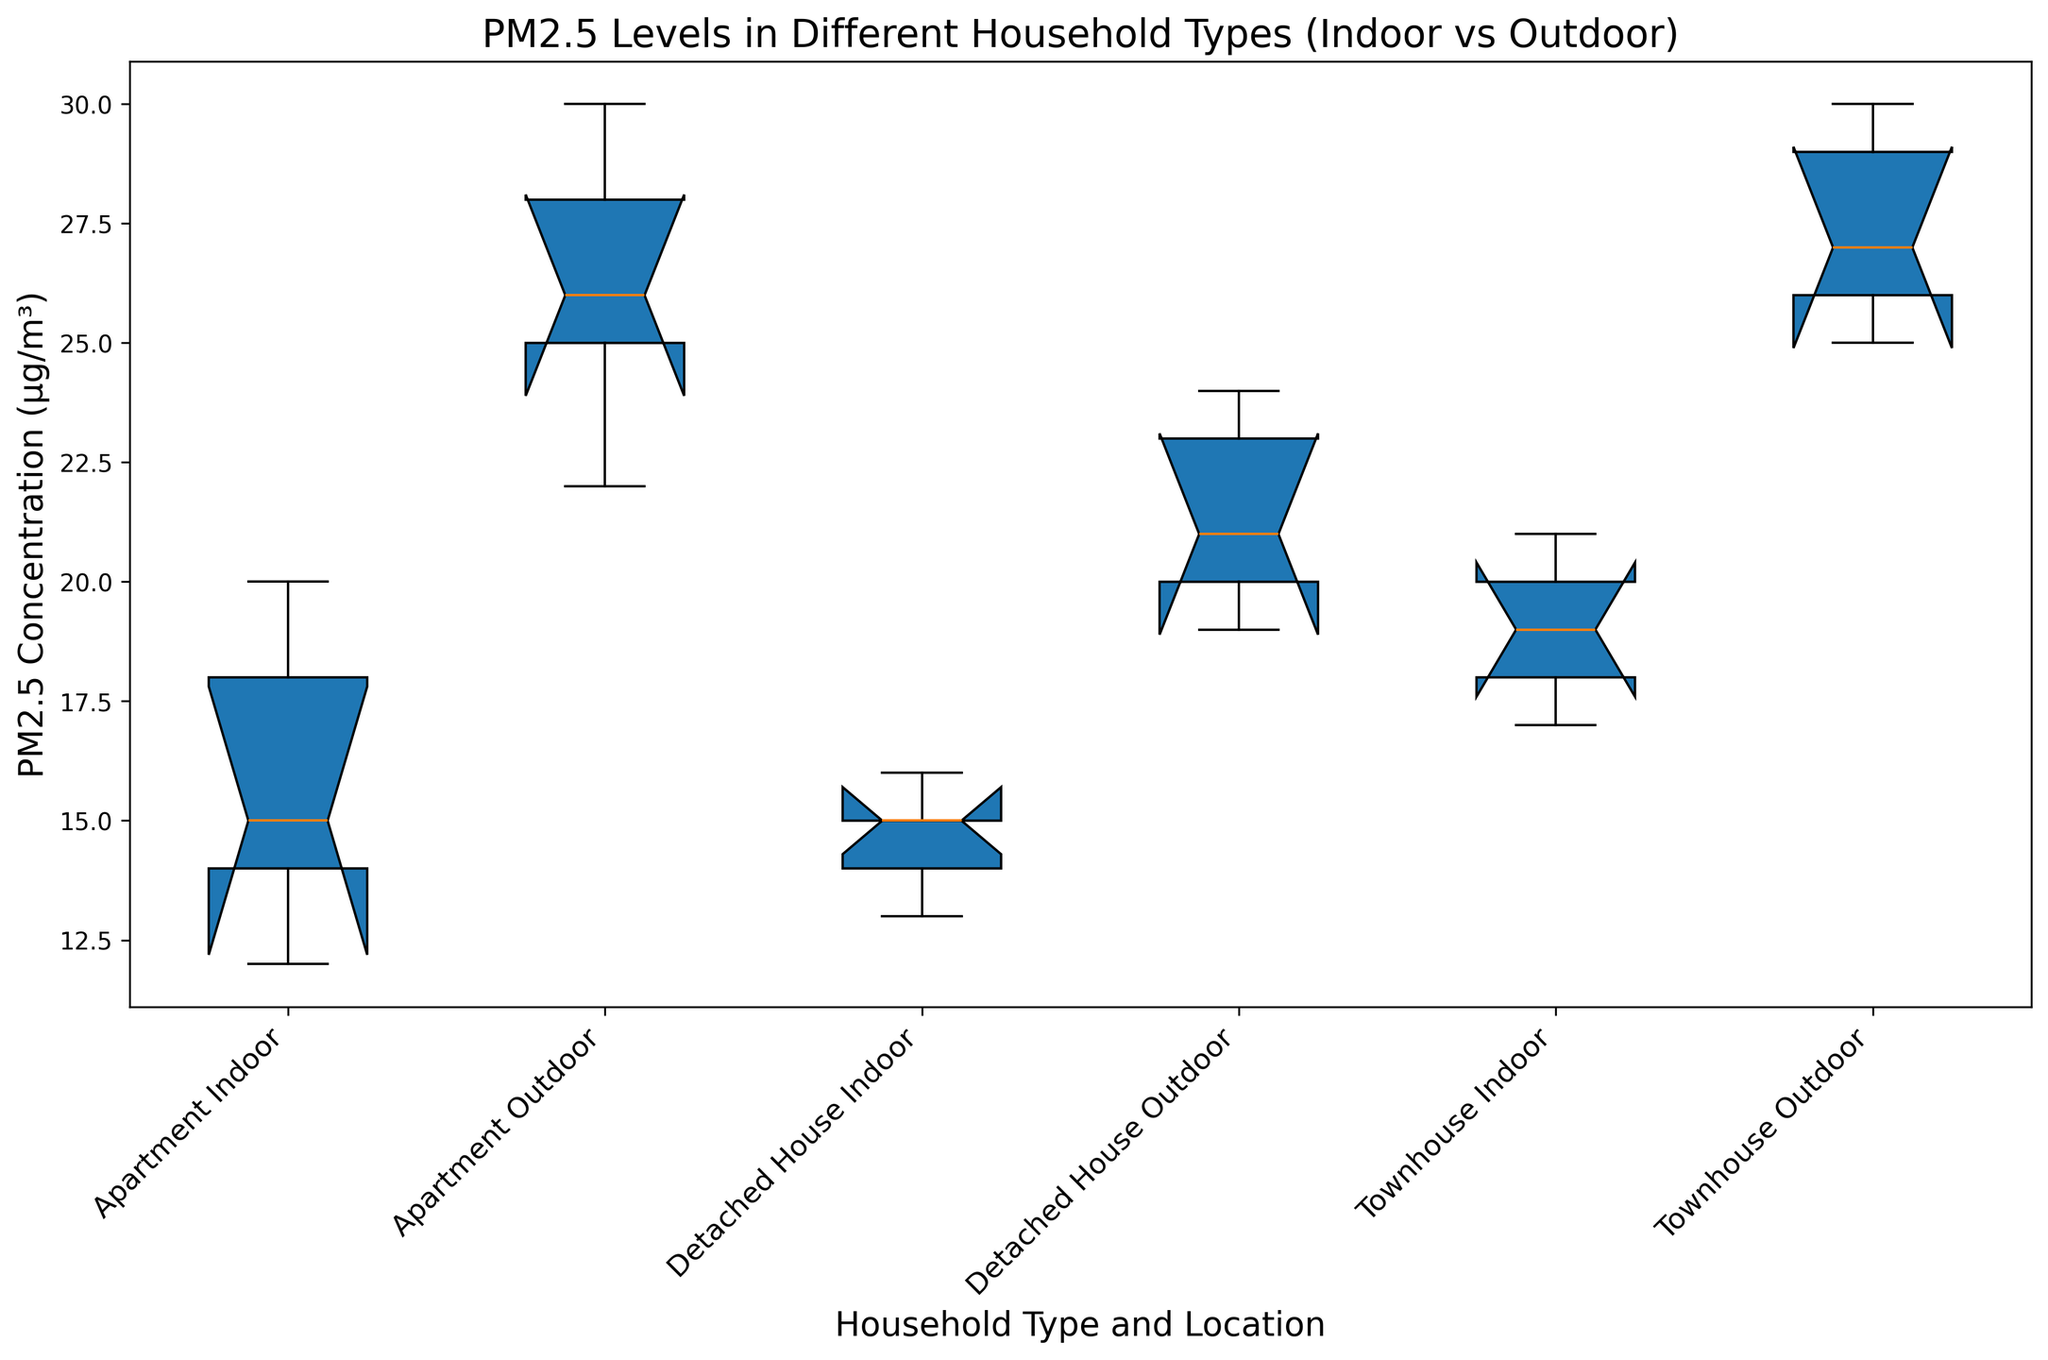What's the overall median PM2.5 concentration for Apartments (including both Indoor and Outdoor)? Calculate the median values of both groups (Indoor and Outdoor) separately, then determine the middle number of the combined list 12, 14, 15, 18, 20 (Indoor) and 22, 25, 26, 28, 30 (Outdoor). Combining and sorting these values gives 12, 14, 15, 18, 20, 22, 25, 26, 28, 30. The median value is the average of 20 and 22, which is 21.
Answer: 21 Which household type has the highest median PM2.5 concentration outdoors? Compare the median values of PM2.5 concentrations outdoors for Apartments, Detached Houses, and Townhouses. The respective median values are: 26 for Apartments, 21 for Detached Houses, and 27 for Townhouses. Therefore, Townhouses have the highest median PM2.5 concentration.
Answer: Townhouses Looking at the boxes, which household type has less variation in indoor PM2.5 levels? Assess the length of the boxes for indoor PM2.5 levels for each household type. The boxes represent the interquartile ranges (IQR). The smaller the IQR, the less variation. Among Apartments, Detached Houses, and Townhouses, the Detached Houses have the smallest IQR, indicating less variation.
Answer: Detached Houses Does indoor or outdoor PM2.5 concentration generally seem higher across household types? Compare the vertical positions of the boxes representing indoor and outdoor PM2.5 levels for Apartments, Detached Houses, and Townhouses. In all cases, the outdoor boxes are higher than the indoor ones, indicating higher concentration levels outdoors.
Answer: Outdoor What's the range of the PM2.5 concentrations for Townhouses Outdoors? Identify the minimum and maximum values (whiskers) of the Townhouse Outdoor box plot. These whiskers extend from 25 to 30, giving us the range.
Answer: 5 Which household type and location has the lowest median PM2.5 level and what is it? Compare the median lines within the boxes. The lowest median PM2.5 level is in Detached Houses Indoor, which is at 15.
Answer: Detached Houses Indoor, 15 How does the variance in Outdoor PM2.5 concentration for Apartments compare to Townhouses? Compare the length of the boxes (IQR) for Apartments and Townhouses in the Outdoor category. Apartments have a box length from 22 to 28 (IQR = 6), while Townhouses have a box length from 25 to 29 (IQR = 4). Apartments exhibit higher variance.
Answer: Apartments have higher variance Are there any visible outliers in the PM2.5 levels for any household type and location? Look for points outside the whiskers of the box plots. There are no individual points plotted beyond the whiskers, indicating no visible outliers in this dataset.
Answer: No 